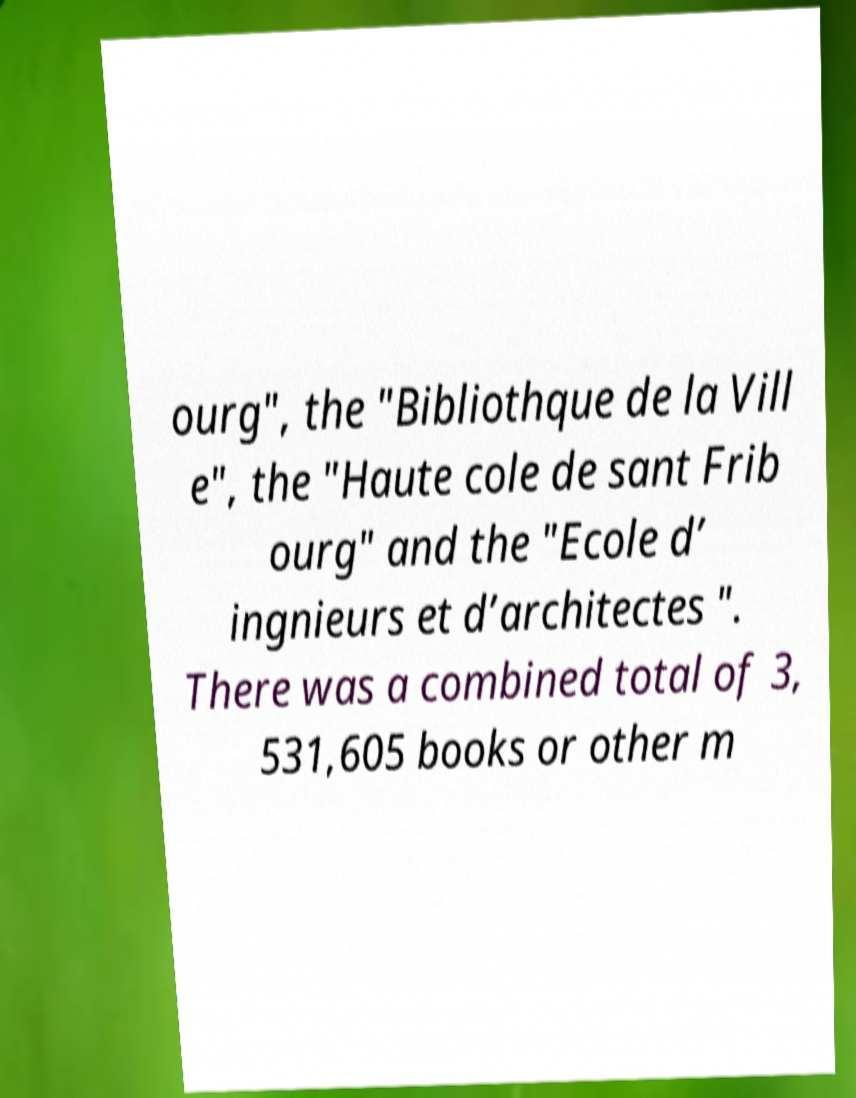For documentation purposes, I need the text within this image transcribed. Could you provide that? ourg", the "Bibliothque de la Vill e", the "Haute cole de sant Frib ourg" and the "Ecole d’ ingnieurs et d’architectes ". There was a combined total of 3, 531,605 books or other m 